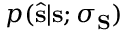<formula> <loc_0><loc_0><loc_500><loc_500>p ( \hat { s } | s ; \sigma _ { S } )</formula> 